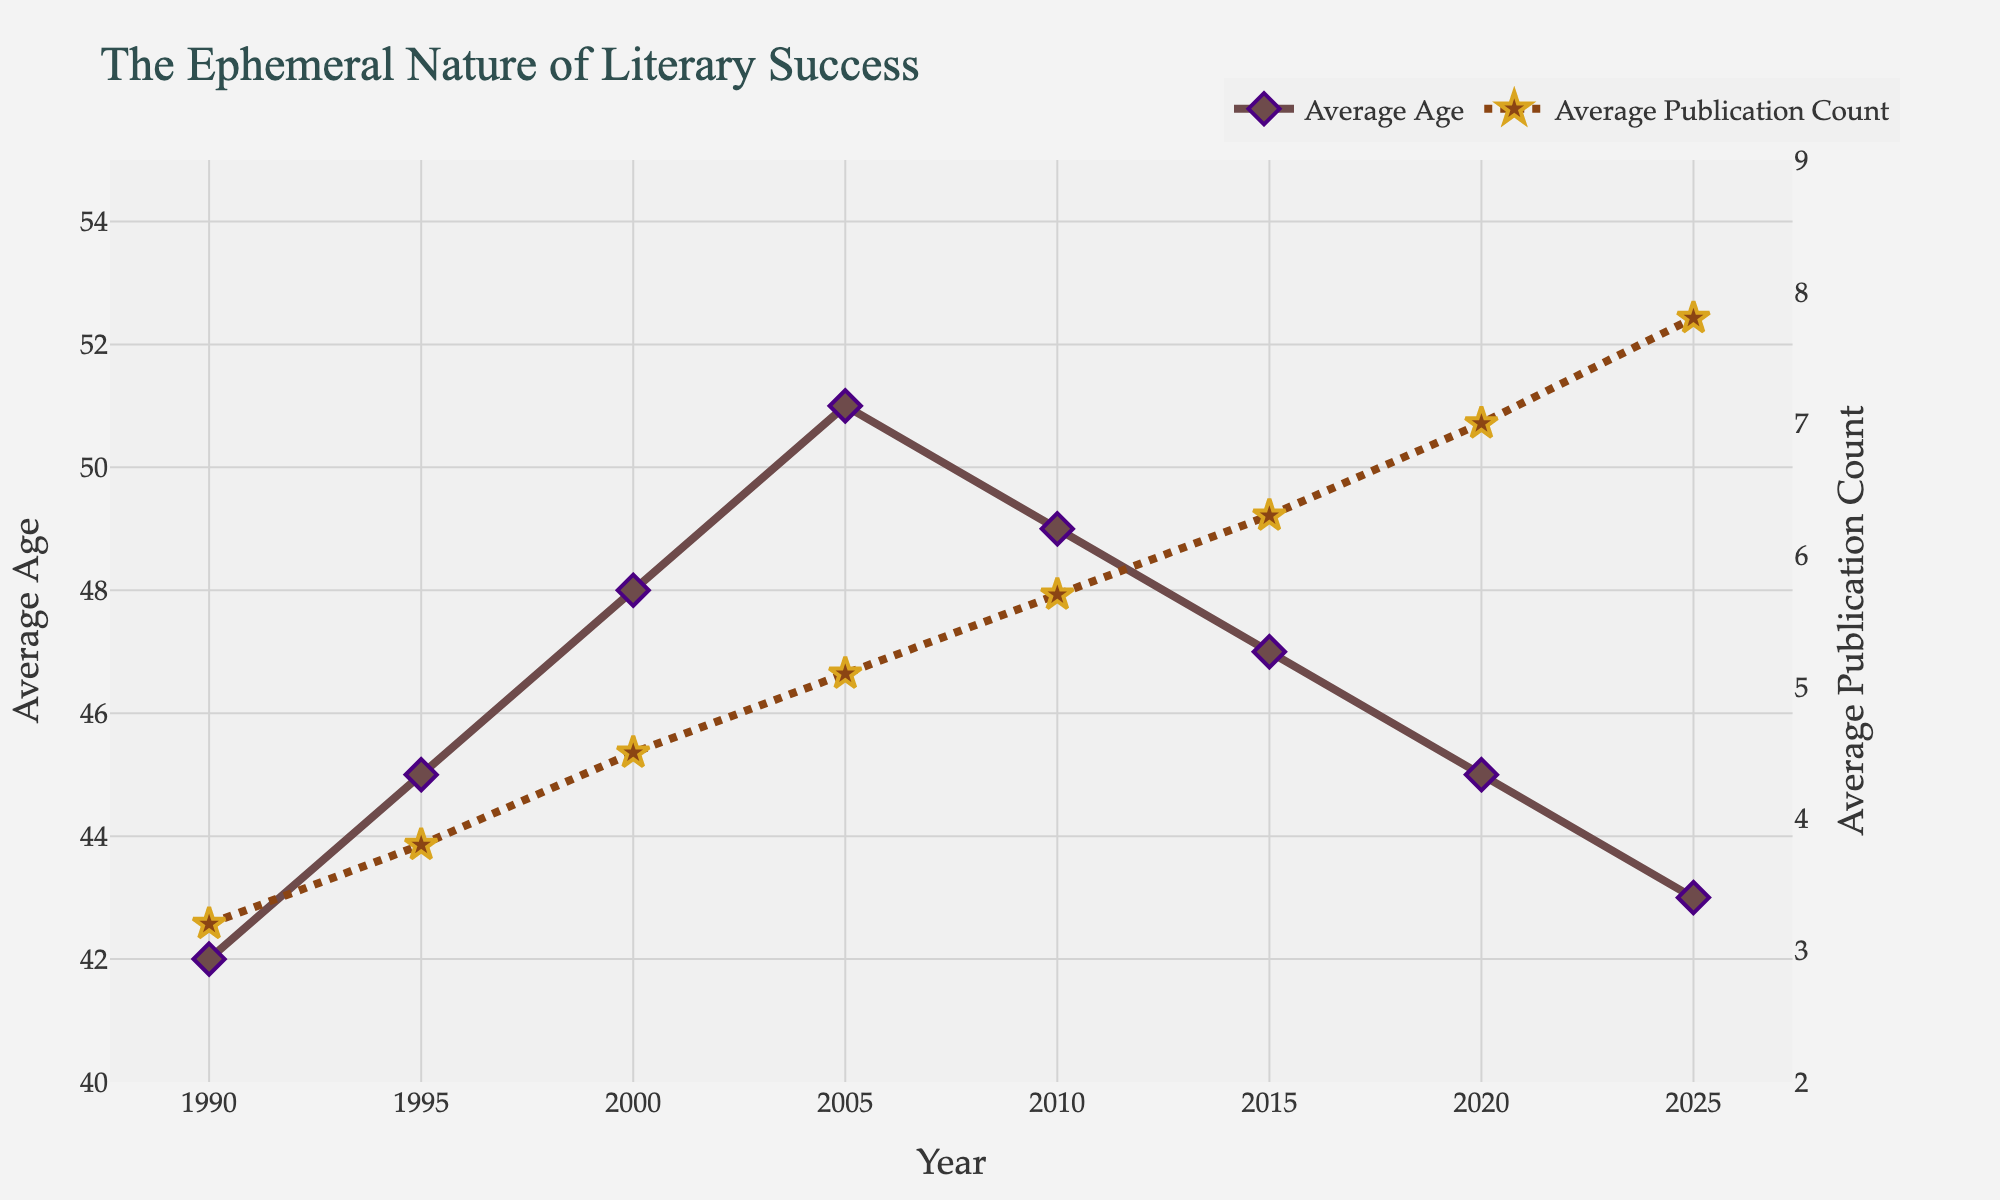What is the trend in the average age of literary award winners from 1990 to 2025? To determine the trend, we need to observe the changes in the average age over the years. Initially, it rises from 42 in 1990 to 51 in 2005, then declines to 43 by 2025.
Answer: It increases initially and then decreases What is the trend in the average publication count of literary award winners from 1990 to 2025? Observing the average publication count over the years, we see a steady increase from 3.2 in 1990 to 7.8 in 2025.
Answer: It steadily increases In which year did the average age of literary award winners reach its peak? We need to identify the highest value of average age on the chart. The peak is 51 in the year 2005.
Answer: 2005 How do the average age and publication count compare between 1990 and 2025? For comparison, note the values in both years: in 1990, the average age is 42 and the publication count is 3.2. By 2025, the average age is 43 and the publication count is 7.8.
Answer: In 2025, the age is slightly higher, but the publication count is significantly higher What is the difference in the average publication count between the highest and lowest years? The lowest publication count is 3.2 in 1990, and the highest is 7.8 in 2025. The difference is 7.8 - 3.2 = 4.6.
Answer: 4.6 Which year experienced the steepest increase in average publication count? To find this, identify the year-to-year differences. From 2015 to 2020, the count increases from 6.3 to 7.0, the steepest rise of 0.7.
Answer: 2015 to 2020 During which period did the average age of literary winners decrease the most? Analyzing year-to-year differences, the greatest decrease occurs from 2005 (age 51) to 2010 (age 49), a drop of 2 years.
Answer: 2005 to 2010 By how much did the average age differ between the year with the highest average age and the year with the lowest average age? The highest average age is 51 in 2005, and the lowest is 42 in 1990. The difference is 51 - 42 = 9 years.
Answer: 9 What colors are used to represent the average age and average publication count in the chart? The average age is represented by a line and markers in a purple-brown color, while the average publication count is depicted with a brown line and gold star markers.
Answer: Purple-brown for age, brown and gold for publications What is the difference between the average age in 2000 and the average publication count in 2000? In 2000, the average age is 48 and the average publication count is 4.5. The difference is 48 - 4.5 = 43.5.
Answer: 43.5 